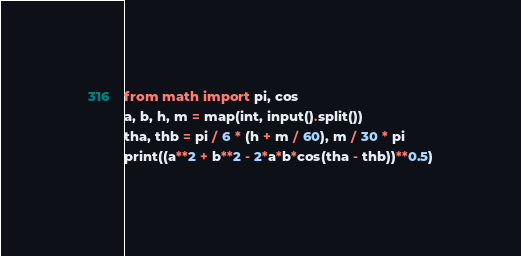<code> <loc_0><loc_0><loc_500><loc_500><_Python_>from math import pi, cos
a, b, h, m = map(int, input().split())
tha, thb = pi / 6 * (h + m / 60), m / 30 * pi
print((a**2 + b**2 - 2*a*b*cos(tha - thb))**0.5)</code> 